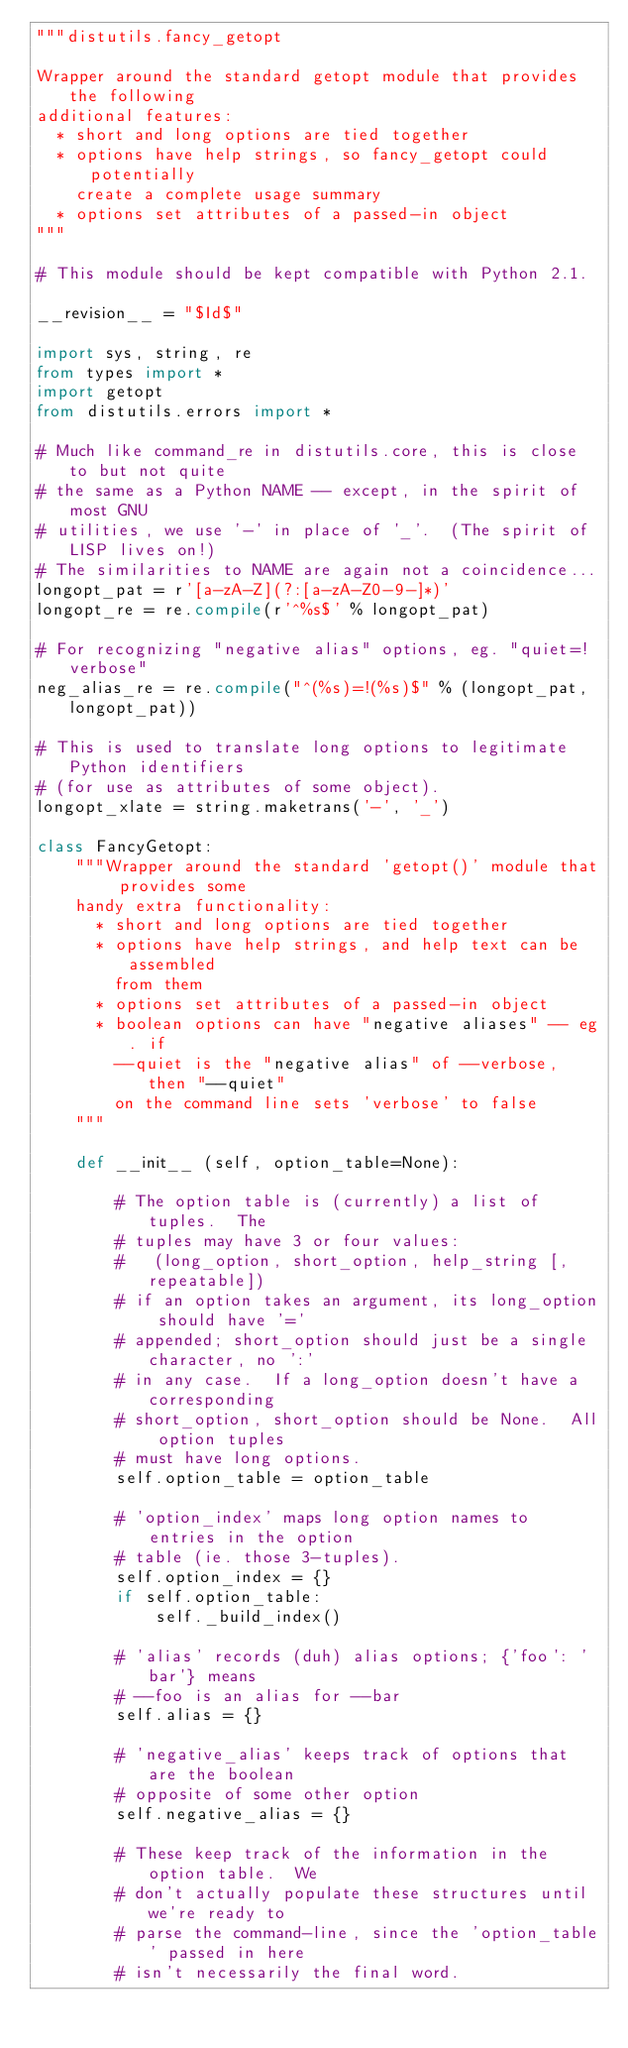Convert code to text. <code><loc_0><loc_0><loc_500><loc_500><_Python_>"""distutils.fancy_getopt

Wrapper around the standard getopt module that provides the following
additional features:
  * short and long options are tied together
  * options have help strings, so fancy_getopt could potentially
    create a complete usage summary
  * options set attributes of a passed-in object
"""

# This module should be kept compatible with Python 2.1.

__revision__ = "$Id$"

import sys, string, re
from types import *
import getopt
from distutils.errors import *

# Much like command_re in distutils.core, this is close to but not quite
# the same as a Python NAME -- except, in the spirit of most GNU
# utilities, we use '-' in place of '_'.  (The spirit of LISP lives on!)
# The similarities to NAME are again not a coincidence...
longopt_pat = r'[a-zA-Z](?:[a-zA-Z0-9-]*)'
longopt_re = re.compile(r'^%s$' % longopt_pat)

# For recognizing "negative alias" options, eg. "quiet=!verbose"
neg_alias_re = re.compile("^(%s)=!(%s)$" % (longopt_pat, longopt_pat))

# This is used to translate long options to legitimate Python identifiers
# (for use as attributes of some object).
longopt_xlate = string.maketrans('-', '_')

class FancyGetopt:
    """Wrapper around the standard 'getopt()' module that provides some
    handy extra functionality:
      * short and long options are tied together
      * options have help strings, and help text can be assembled
        from them
      * options set attributes of a passed-in object
      * boolean options can have "negative aliases" -- eg. if
        --quiet is the "negative alias" of --verbose, then "--quiet"
        on the command line sets 'verbose' to false
    """

    def __init__ (self, option_table=None):

        # The option table is (currently) a list of tuples.  The
        # tuples may have 3 or four values:
        #   (long_option, short_option, help_string [, repeatable])
        # if an option takes an argument, its long_option should have '='
        # appended; short_option should just be a single character, no ':'
        # in any case.  If a long_option doesn't have a corresponding
        # short_option, short_option should be None.  All option tuples
        # must have long options.
        self.option_table = option_table

        # 'option_index' maps long option names to entries in the option
        # table (ie. those 3-tuples).
        self.option_index = {}
        if self.option_table:
            self._build_index()

        # 'alias' records (duh) alias options; {'foo': 'bar'} means
        # --foo is an alias for --bar
        self.alias = {}

        # 'negative_alias' keeps track of options that are the boolean
        # opposite of some other option
        self.negative_alias = {}

        # These keep track of the information in the option table.  We
        # don't actually populate these structures until we're ready to
        # parse the command-line, since the 'option_table' passed in here
        # isn't necessarily the final word.</code> 